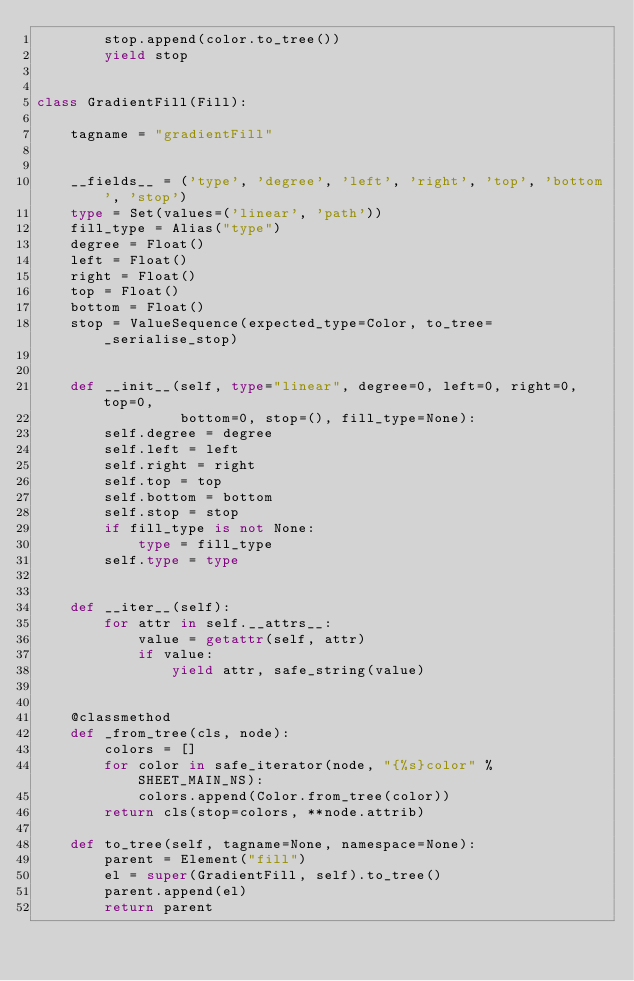<code> <loc_0><loc_0><loc_500><loc_500><_Python_>        stop.append(color.to_tree())
        yield stop


class GradientFill(Fill):

    tagname = "gradientFill"


    __fields__ = ('type', 'degree', 'left', 'right', 'top', 'bottom', 'stop')
    type = Set(values=('linear', 'path'))
    fill_type = Alias("type")
    degree = Float()
    left = Float()
    right = Float()
    top = Float()
    bottom = Float()
    stop = ValueSequence(expected_type=Color, to_tree=_serialise_stop)


    def __init__(self, type="linear", degree=0, left=0, right=0, top=0,
                 bottom=0, stop=(), fill_type=None):
        self.degree = degree
        self.left = left
        self.right = right
        self.top = top
        self.bottom = bottom
        self.stop = stop
        if fill_type is not None:
            type = fill_type
        self.type = type


    def __iter__(self):
        for attr in self.__attrs__:
            value = getattr(self, attr)
            if value:
                yield attr, safe_string(value)


    @classmethod
    def _from_tree(cls, node):
        colors = []
        for color in safe_iterator(node, "{%s}color" % SHEET_MAIN_NS):
            colors.append(Color.from_tree(color))
        return cls(stop=colors, **node.attrib)

    def to_tree(self, tagname=None, namespace=None):
        parent = Element("fill")
        el = super(GradientFill, self).to_tree()
        parent.append(el)
        return parent
</code> 